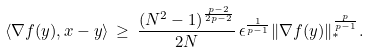Convert formula to latex. <formula><loc_0><loc_0><loc_500><loc_500>\langle \nabla f ( y ) , x - y \rangle \, \geq \, \frac { ( N ^ { 2 } - 1 ) ^ { \frac { p - 2 } { 2 p - 2 } } } { 2 N } \, \epsilon ^ { \frac { 1 } { p - 1 } } \| \nabla f ( y ) \| _ { * } ^ { \frac { p } { p - 1 } } .</formula> 